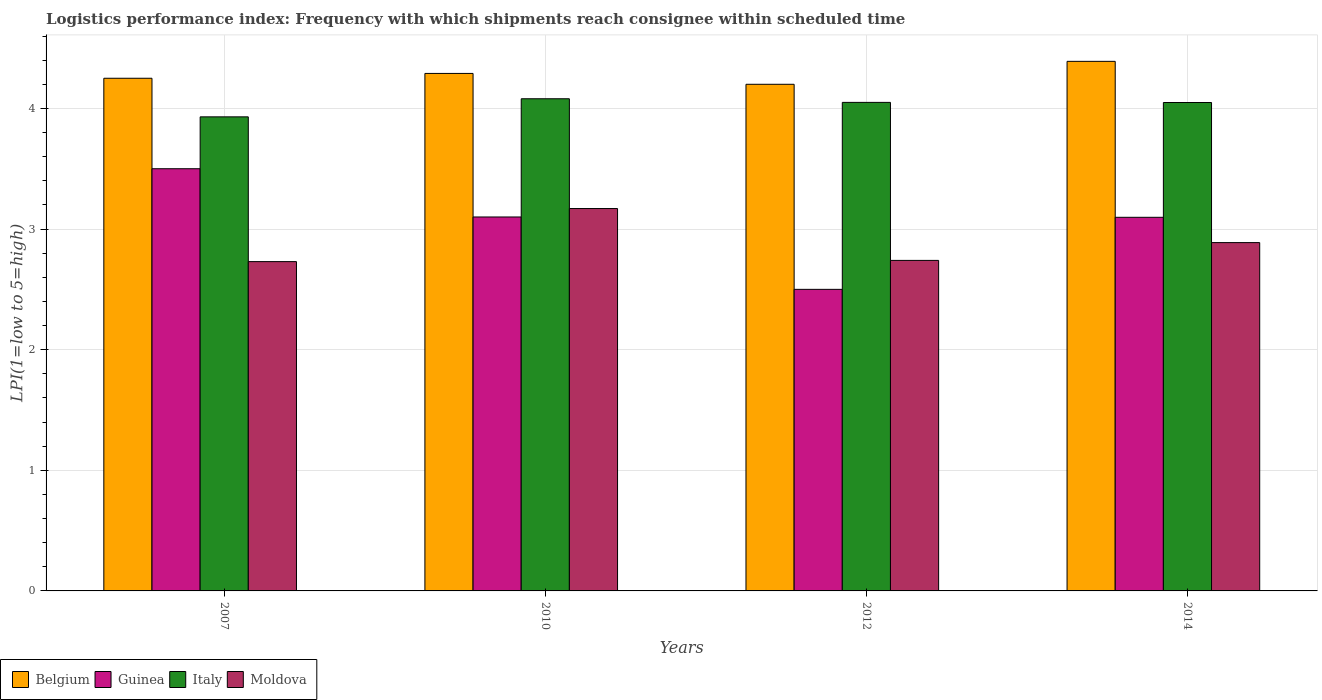Are the number of bars per tick equal to the number of legend labels?
Your response must be concise. Yes. Are the number of bars on each tick of the X-axis equal?
Your response must be concise. Yes. How many bars are there on the 3rd tick from the left?
Provide a short and direct response. 4. What is the label of the 1st group of bars from the left?
Offer a very short reply. 2007. What is the logistics performance index in Italy in 2010?
Your answer should be compact. 4.08. Across all years, what is the maximum logistics performance index in Belgium?
Your answer should be compact. 4.39. What is the total logistics performance index in Guinea in the graph?
Make the answer very short. 12.2. What is the difference between the logistics performance index in Italy in 2007 and that in 2010?
Offer a terse response. -0.15. What is the difference between the logistics performance index in Belgium in 2010 and the logistics performance index in Guinea in 2014?
Your answer should be very brief. 1.19. What is the average logistics performance index in Guinea per year?
Make the answer very short. 3.05. In the year 2012, what is the difference between the logistics performance index in Moldova and logistics performance index in Guinea?
Offer a very short reply. 0.24. What is the ratio of the logistics performance index in Belgium in 2007 to that in 2010?
Give a very brief answer. 0.99. Is the difference between the logistics performance index in Moldova in 2007 and 2014 greater than the difference between the logistics performance index in Guinea in 2007 and 2014?
Your response must be concise. No. What is the difference between the highest and the second highest logistics performance index in Guinea?
Your answer should be very brief. 0.4. What is the difference between the highest and the lowest logistics performance index in Italy?
Give a very brief answer. 0.15. Is it the case that in every year, the sum of the logistics performance index in Italy and logistics performance index in Belgium is greater than the sum of logistics performance index in Guinea and logistics performance index in Moldova?
Offer a terse response. Yes. What does the 4th bar from the right in 2007 represents?
Provide a short and direct response. Belgium. Is it the case that in every year, the sum of the logistics performance index in Moldova and logistics performance index in Italy is greater than the logistics performance index in Belgium?
Offer a very short reply. Yes. How many bars are there?
Offer a terse response. 16. Does the graph contain grids?
Your answer should be very brief. Yes. How many legend labels are there?
Keep it short and to the point. 4. How are the legend labels stacked?
Ensure brevity in your answer.  Horizontal. What is the title of the graph?
Provide a short and direct response. Logistics performance index: Frequency with which shipments reach consignee within scheduled time. Does "Barbados" appear as one of the legend labels in the graph?
Your response must be concise. No. What is the label or title of the Y-axis?
Provide a short and direct response. LPI(1=low to 5=high). What is the LPI(1=low to 5=high) of Belgium in 2007?
Offer a terse response. 4.25. What is the LPI(1=low to 5=high) of Italy in 2007?
Your response must be concise. 3.93. What is the LPI(1=low to 5=high) in Moldova in 2007?
Your response must be concise. 2.73. What is the LPI(1=low to 5=high) of Belgium in 2010?
Offer a terse response. 4.29. What is the LPI(1=low to 5=high) in Guinea in 2010?
Your answer should be very brief. 3.1. What is the LPI(1=low to 5=high) of Italy in 2010?
Give a very brief answer. 4.08. What is the LPI(1=low to 5=high) in Moldova in 2010?
Your answer should be very brief. 3.17. What is the LPI(1=low to 5=high) in Italy in 2012?
Provide a short and direct response. 4.05. What is the LPI(1=low to 5=high) of Moldova in 2012?
Keep it short and to the point. 2.74. What is the LPI(1=low to 5=high) in Belgium in 2014?
Give a very brief answer. 4.39. What is the LPI(1=low to 5=high) of Guinea in 2014?
Provide a short and direct response. 3.1. What is the LPI(1=low to 5=high) of Italy in 2014?
Offer a very short reply. 4.05. What is the LPI(1=low to 5=high) of Moldova in 2014?
Keep it short and to the point. 2.89. Across all years, what is the maximum LPI(1=low to 5=high) in Belgium?
Your response must be concise. 4.39. Across all years, what is the maximum LPI(1=low to 5=high) of Guinea?
Your answer should be compact. 3.5. Across all years, what is the maximum LPI(1=low to 5=high) of Italy?
Your answer should be compact. 4.08. Across all years, what is the maximum LPI(1=low to 5=high) in Moldova?
Your answer should be very brief. 3.17. Across all years, what is the minimum LPI(1=low to 5=high) of Belgium?
Provide a short and direct response. 4.2. Across all years, what is the minimum LPI(1=low to 5=high) in Guinea?
Offer a very short reply. 2.5. Across all years, what is the minimum LPI(1=low to 5=high) of Italy?
Provide a succinct answer. 3.93. Across all years, what is the minimum LPI(1=low to 5=high) of Moldova?
Make the answer very short. 2.73. What is the total LPI(1=low to 5=high) of Belgium in the graph?
Provide a succinct answer. 17.13. What is the total LPI(1=low to 5=high) of Guinea in the graph?
Keep it short and to the point. 12.2. What is the total LPI(1=low to 5=high) of Italy in the graph?
Offer a very short reply. 16.11. What is the total LPI(1=low to 5=high) in Moldova in the graph?
Make the answer very short. 11.53. What is the difference between the LPI(1=low to 5=high) in Belgium in 2007 and that in 2010?
Keep it short and to the point. -0.04. What is the difference between the LPI(1=low to 5=high) of Guinea in 2007 and that in 2010?
Offer a terse response. 0.4. What is the difference between the LPI(1=low to 5=high) of Moldova in 2007 and that in 2010?
Your answer should be compact. -0.44. What is the difference between the LPI(1=low to 5=high) of Guinea in 2007 and that in 2012?
Offer a terse response. 1. What is the difference between the LPI(1=low to 5=high) in Italy in 2007 and that in 2012?
Make the answer very short. -0.12. What is the difference between the LPI(1=low to 5=high) in Moldova in 2007 and that in 2012?
Offer a terse response. -0.01. What is the difference between the LPI(1=low to 5=high) in Belgium in 2007 and that in 2014?
Your response must be concise. -0.14. What is the difference between the LPI(1=low to 5=high) in Guinea in 2007 and that in 2014?
Ensure brevity in your answer.  0.4. What is the difference between the LPI(1=low to 5=high) of Italy in 2007 and that in 2014?
Offer a very short reply. -0.12. What is the difference between the LPI(1=low to 5=high) in Moldova in 2007 and that in 2014?
Your answer should be compact. -0.16. What is the difference between the LPI(1=low to 5=high) in Belgium in 2010 and that in 2012?
Provide a short and direct response. 0.09. What is the difference between the LPI(1=low to 5=high) in Guinea in 2010 and that in 2012?
Offer a terse response. 0.6. What is the difference between the LPI(1=low to 5=high) in Moldova in 2010 and that in 2012?
Give a very brief answer. 0.43. What is the difference between the LPI(1=low to 5=high) in Belgium in 2010 and that in 2014?
Ensure brevity in your answer.  -0.1. What is the difference between the LPI(1=low to 5=high) in Guinea in 2010 and that in 2014?
Your answer should be very brief. 0. What is the difference between the LPI(1=low to 5=high) of Italy in 2010 and that in 2014?
Ensure brevity in your answer.  0.03. What is the difference between the LPI(1=low to 5=high) in Moldova in 2010 and that in 2014?
Provide a short and direct response. 0.28. What is the difference between the LPI(1=low to 5=high) of Belgium in 2012 and that in 2014?
Offer a terse response. -0.19. What is the difference between the LPI(1=low to 5=high) in Guinea in 2012 and that in 2014?
Keep it short and to the point. -0.6. What is the difference between the LPI(1=low to 5=high) of Moldova in 2012 and that in 2014?
Your answer should be very brief. -0.15. What is the difference between the LPI(1=low to 5=high) in Belgium in 2007 and the LPI(1=low to 5=high) in Guinea in 2010?
Provide a succinct answer. 1.15. What is the difference between the LPI(1=low to 5=high) in Belgium in 2007 and the LPI(1=low to 5=high) in Italy in 2010?
Your answer should be compact. 0.17. What is the difference between the LPI(1=low to 5=high) of Belgium in 2007 and the LPI(1=low to 5=high) of Moldova in 2010?
Provide a succinct answer. 1.08. What is the difference between the LPI(1=low to 5=high) of Guinea in 2007 and the LPI(1=low to 5=high) of Italy in 2010?
Your answer should be compact. -0.58. What is the difference between the LPI(1=low to 5=high) in Guinea in 2007 and the LPI(1=low to 5=high) in Moldova in 2010?
Your answer should be very brief. 0.33. What is the difference between the LPI(1=low to 5=high) of Italy in 2007 and the LPI(1=low to 5=high) of Moldova in 2010?
Your response must be concise. 0.76. What is the difference between the LPI(1=low to 5=high) in Belgium in 2007 and the LPI(1=low to 5=high) in Italy in 2012?
Provide a succinct answer. 0.2. What is the difference between the LPI(1=low to 5=high) in Belgium in 2007 and the LPI(1=low to 5=high) in Moldova in 2012?
Offer a terse response. 1.51. What is the difference between the LPI(1=low to 5=high) in Guinea in 2007 and the LPI(1=low to 5=high) in Italy in 2012?
Your answer should be very brief. -0.55. What is the difference between the LPI(1=low to 5=high) of Guinea in 2007 and the LPI(1=low to 5=high) of Moldova in 2012?
Offer a terse response. 0.76. What is the difference between the LPI(1=low to 5=high) in Italy in 2007 and the LPI(1=low to 5=high) in Moldova in 2012?
Provide a succinct answer. 1.19. What is the difference between the LPI(1=low to 5=high) of Belgium in 2007 and the LPI(1=low to 5=high) of Guinea in 2014?
Ensure brevity in your answer.  1.15. What is the difference between the LPI(1=low to 5=high) in Belgium in 2007 and the LPI(1=low to 5=high) in Italy in 2014?
Make the answer very short. 0.2. What is the difference between the LPI(1=low to 5=high) of Belgium in 2007 and the LPI(1=low to 5=high) of Moldova in 2014?
Keep it short and to the point. 1.36. What is the difference between the LPI(1=low to 5=high) in Guinea in 2007 and the LPI(1=low to 5=high) in Italy in 2014?
Your answer should be compact. -0.55. What is the difference between the LPI(1=low to 5=high) in Guinea in 2007 and the LPI(1=low to 5=high) in Moldova in 2014?
Make the answer very short. 0.61. What is the difference between the LPI(1=low to 5=high) in Italy in 2007 and the LPI(1=low to 5=high) in Moldova in 2014?
Your response must be concise. 1.04. What is the difference between the LPI(1=low to 5=high) of Belgium in 2010 and the LPI(1=low to 5=high) of Guinea in 2012?
Provide a short and direct response. 1.79. What is the difference between the LPI(1=low to 5=high) of Belgium in 2010 and the LPI(1=low to 5=high) of Italy in 2012?
Ensure brevity in your answer.  0.24. What is the difference between the LPI(1=low to 5=high) of Belgium in 2010 and the LPI(1=low to 5=high) of Moldova in 2012?
Keep it short and to the point. 1.55. What is the difference between the LPI(1=low to 5=high) of Guinea in 2010 and the LPI(1=low to 5=high) of Italy in 2012?
Ensure brevity in your answer.  -0.95. What is the difference between the LPI(1=low to 5=high) in Guinea in 2010 and the LPI(1=low to 5=high) in Moldova in 2012?
Offer a very short reply. 0.36. What is the difference between the LPI(1=low to 5=high) in Italy in 2010 and the LPI(1=low to 5=high) in Moldova in 2012?
Make the answer very short. 1.34. What is the difference between the LPI(1=low to 5=high) in Belgium in 2010 and the LPI(1=low to 5=high) in Guinea in 2014?
Keep it short and to the point. 1.19. What is the difference between the LPI(1=low to 5=high) of Belgium in 2010 and the LPI(1=low to 5=high) of Italy in 2014?
Your answer should be compact. 0.24. What is the difference between the LPI(1=low to 5=high) of Belgium in 2010 and the LPI(1=low to 5=high) of Moldova in 2014?
Keep it short and to the point. 1.4. What is the difference between the LPI(1=low to 5=high) of Guinea in 2010 and the LPI(1=low to 5=high) of Italy in 2014?
Ensure brevity in your answer.  -0.95. What is the difference between the LPI(1=low to 5=high) in Guinea in 2010 and the LPI(1=low to 5=high) in Moldova in 2014?
Keep it short and to the point. 0.21. What is the difference between the LPI(1=low to 5=high) in Italy in 2010 and the LPI(1=low to 5=high) in Moldova in 2014?
Your answer should be compact. 1.19. What is the difference between the LPI(1=low to 5=high) in Belgium in 2012 and the LPI(1=low to 5=high) in Guinea in 2014?
Your response must be concise. 1.1. What is the difference between the LPI(1=low to 5=high) in Belgium in 2012 and the LPI(1=low to 5=high) in Italy in 2014?
Offer a very short reply. 0.15. What is the difference between the LPI(1=low to 5=high) of Belgium in 2012 and the LPI(1=low to 5=high) of Moldova in 2014?
Give a very brief answer. 1.31. What is the difference between the LPI(1=low to 5=high) in Guinea in 2012 and the LPI(1=low to 5=high) in Italy in 2014?
Make the answer very short. -1.55. What is the difference between the LPI(1=low to 5=high) of Guinea in 2012 and the LPI(1=low to 5=high) of Moldova in 2014?
Your answer should be compact. -0.39. What is the difference between the LPI(1=low to 5=high) in Italy in 2012 and the LPI(1=low to 5=high) in Moldova in 2014?
Your response must be concise. 1.16. What is the average LPI(1=low to 5=high) of Belgium per year?
Provide a succinct answer. 4.28. What is the average LPI(1=low to 5=high) in Guinea per year?
Provide a succinct answer. 3.05. What is the average LPI(1=low to 5=high) in Italy per year?
Provide a short and direct response. 4.03. What is the average LPI(1=low to 5=high) of Moldova per year?
Ensure brevity in your answer.  2.88. In the year 2007, what is the difference between the LPI(1=low to 5=high) of Belgium and LPI(1=low to 5=high) of Italy?
Your answer should be very brief. 0.32. In the year 2007, what is the difference between the LPI(1=low to 5=high) in Belgium and LPI(1=low to 5=high) in Moldova?
Give a very brief answer. 1.52. In the year 2007, what is the difference between the LPI(1=low to 5=high) in Guinea and LPI(1=low to 5=high) in Italy?
Keep it short and to the point. -0.43. In the year 2007, what is the difference between the LPI(1=low to 5=high) in Guinea and LPI(1=low to 5=high) in Moldova?
Your answer should be compact. 0.77. In the year 2010, what is the difference between the LPI(1=low to 5=high) in Belgium and LPI(1=low to 5=high) in Guinea?
Ensure brevity in your answer.  1.19. In the year 2010, what is the difference between the LPI(1=low to 5=high) in Belgium and LPI(1=low to 5=high) in Italy?
Your answer should be very brief. 0.21. In the year 2010, what is the difference between the LPI(1=low to 5=high) of Belgium and LPI(1=low to 5=high) of Moldova?
Offer a very short reply. 1.12. In the year 2010, what is the difference between the LPI(1=low to 5=high) of Guinea and LPI(1=low to 5=high) of Italy?
Your answer should be very brief. -0.98. In the year 2010, what is the difference between the LPI(1=low to 5=high) of Guinea and LPI(1=low to 5=high) of Moldova?
Provide a short and direct response. -0.07. In the year 2010, what is the difference between the LPI(1=low to 5=high) of Italy and LPI(1=low to 5=high) of Moldova?
Ensure brevity in your answer.  0.91. In the year 2012, what is the difference between the LPI(1=low to 5=high) of Belgium and LPI(1=low to 5=high) of Italy?
Offer a very short reply. 0.15. In the year 2012, what is the difference between the LPI(1=low to 5=high) in Belgium and LPI(1=low to 5=high) in Moldova?
Ensure brevity in your answer.  1.46. In the year 2012, what is the difference between the LPI(1=low to 5=high) in Guinea and LPI(1=low to 5=high) in Italy?
Offer a very short reply. -1.55. In the year 2012, what is the difference between the LPI(1=low to 5=high) of Guinea and LPI(1=low to 5=high) of Moldova?
Give a very brief answer. -0.24. In the year 2012, what is the difference between the LPI(1=low to 5=high) of Italy and LPI(1=low to 5=high) of Moldova?
Ensure brevity in your answer.  1.31. In the year 2014, what is the difference between the LPI(1=low to 5=high) in Belgium and LPI(1=low to 5=high) in Guinea?
Your answer should be very brief. 1.29. In the year 2014, what is the difference between the LPI(1=low to 5=high) of Belgium and LPI(1=low to 5=high) of Italy?
Offer a very short reply. 0.34. In the year 2014, what is the difference between the LPI(1=low to 5=high) of Belgium and LPI(1=low to 5=high) of Moldova?
Provide a short and direct response. 1.5. In the year 2014, what is the difference between the LPI(1=low to 5=high) in Guinea and LPI(1=low to 5=high) in Italy?
Your response must be concise. -0.95. In the year 2014, what is the difference between the LPI(1=low to 5=high) in Guinea and LPI(1=low to 5=high) in Moldova?
Give a very brief answer. 0.21. In the year 2014, what is the difference between the LPI(1=low to 5=high) of Italy and LPI(1=low to 5=high) of Moldova?
Provide a succinct answer. 1.16. What is the ratio of the LPI(1=low to 5=high) of Guinea in 2007 to that in 2010?
Offer a terse response. 1.13. What is the ratio of the LPI(1=low to 5=high) in Italy in 2007 to that in 2010?
Offer a very short reply. 0.96. What is the ratio of the LPI(1=low to 5=high) of Moldova in 2007 to that in 2010?
Your response must be concise. 0.86. What is the ratio of the LPI(1=low to 5=high) in Belgium in 2007 to that in 2012?
Provide a short and direct response. 1.01. What is the ratio of the LPI(1=low to 5=high) in Guinea in 2007 to that in 2012?
Offer a terse response. 1.4. What is the ratio of the LPI(1=low to 5=high) of Italy in 2007 to that in 2012?
Your response must be concise. 0.97. What is the ratio of the LPI(1=low to 5=high) in Moldova in 2007 to that in 2012?
Keep it short and to the point. 1. What is the ratio of the LPI(1=low to 5=high) in Belgium in 2007 to that in 2014?
Provide a short and direct response. 0.97. What is the ratio of the LPI(1=low to 5=high) in Guinea in 2007 to that in 2014?
Provide a short and direct response. 1.13. What is the ratio of the LPI(1=low to 5=high) of Italy in 2007 to that in 2014?
Offer a terse response. 0.97. What is the ratio of the LPI(1=low to 5=high) of Moldova in 2007 to that in 2014?
Offer a terse response. 0.95. What is the ratio of the LPI(1=low to 5=high) in Belgium in 2010 to that in 2012?
Your response must be concise. 1.02. What is the ratio of the LPI(1=low to 5=high) of Guinea in 2010 to that in 2012?
Your answer should be compact. 1.24. What is the ratio of the LPI(1=low to 5=high) of Italy in 2010 to that in 2012?
Give a very brief answer. 1.01. What is the ratio of the LPI(1=low to 5=high) in Moldova in 2010 to that in 2012?
Your response must be concise. 1.16. What is the ratio of the LPI(1=low to 5=high) of Belgium in 2010 to that in 2014?
Offer a terse response. 0.98. What is the ratio of the LPI(1=low to 5=high) of Italy in 2010 to that in 2014?
Provide a short and direct response. 1.01. What is the ratio of the LPI(1=low to 5=high) in Moldova in 2010 to that in 2014?
Give a very brief answer. 1.1. What is the ratio of the LPI(1=low to 5=high) in Belgium in 2012 to that in 2014?
Provide a short and direct response. 0.96. What is the ratio of the LPI(1=low to 5=high) of Guinea in 2012 to that in 2014?
Your answer should be compact. 0.81. What is the ratio of the LPI(1=low to 5=high) in Italy in 2012 to that in 2014?
Your answer should be very brief. 1. What is the ratio of the LPI(1=low to 5=high) of Moldova in 2012 to that in 2014?
Make the answer very short. 0.95. What is the difference between the highest and the second highest LPI(1=low to 5=high) in Belgium?
Your answer should be very brief. 0.1. What is the difference between the highest and the second highest LPI(1=low to 5=high) of Guinea?
Give a very brief answer. 0.4. What is the difference between the highest and the second highest LPI(1=low to 5=high) in Italy?
Your answer should be very brief. 0.03. What is the difference between the highest and the second highest LPI(1=low to 5=high) of Moldova?
Offer a terse response. 0.28. What is the difference between the highest and the lowest LPI(1=low to 5=high) in Belgium?
Keep it short and to the point. 0.19. What is the difference between the highest and the lowest LPI(1=low to 5=high) of Moldova?
Your answer should be very brief. 0.44. 